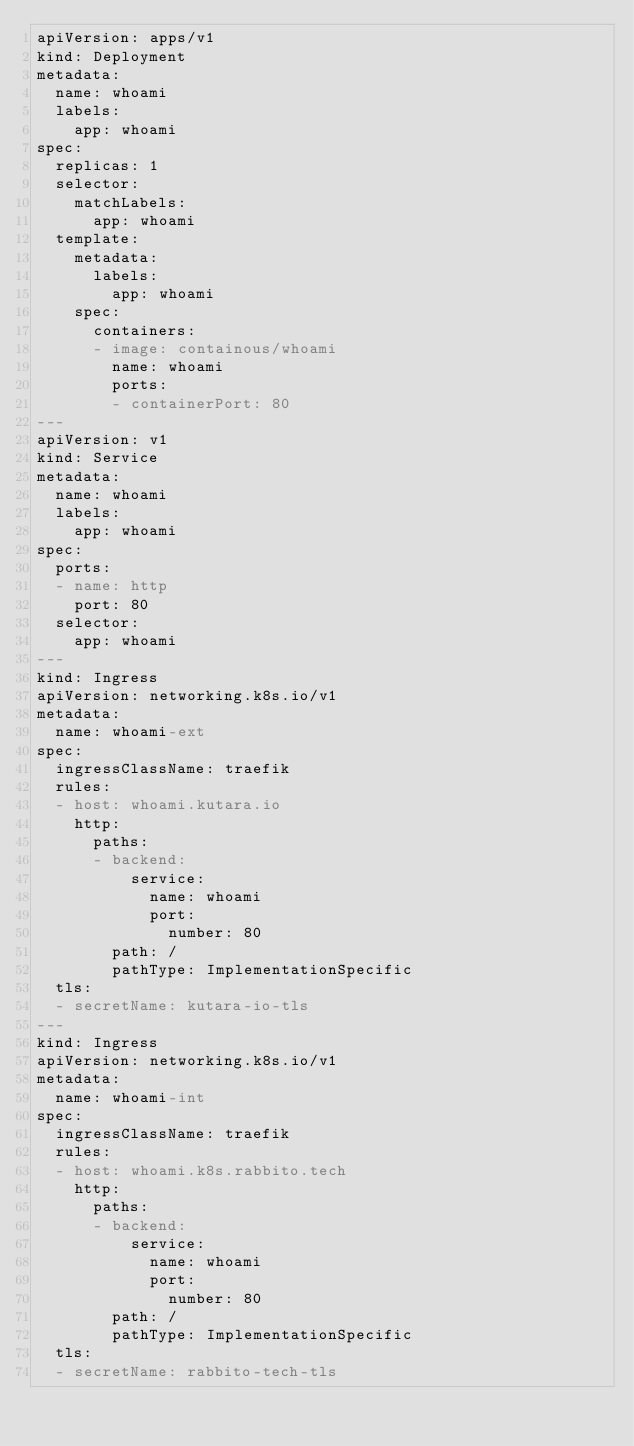Convert code to text. <code><loc_0><loc_0><loc_500><loc_500><_YAML_>apiVersion: apps/v1
kind: Deployment
metadata:
  name: whoami
  labels:
    app: whoami
spec:
  replicas: 1
  selector:
    matchLabels:
      app: whoami
  template:
    metadata:
      labels:
        app: whoami
    spec:
      containers:
      - image: containous/whoami
        name: whoami
        ports:
        - containerPort: 80
---
apiVersion: v1
kind: Service
metadata:
  name: whoami
  labels:
    app: whoami
spec:
  ports:
  - name: http
    port: 80
  selector:
    app: whoami
---
kind: Ingress
apiVersion: networking.k8s.io/v1
metadata:
  name: whoami-ext
spec:
  ingressClassName: traefik
  rules:
  - host: whoami.kutara.io
    http:
      paths:
      - backend:
          service:
            name: whoami
            port:
              number: 80
        path: /
        pathType: ImplementationSpecific
  tls:
  - secretName: kutara-io-tls
---
kind: Ingress
apiVersion: networking.k8s.io/v1
metadata:
  name: whoami-int
spec:
  ingressClassName: traefik
  rules:
  - host: whoami.k8s.rabbito.tech
    http:
      paths:
      - backend:
          service:
            name: whoami
            port:
              number: 80
        path: /
        pathType: ImplementationSpecific
  tls:
  - secretName: rabbito-tech-tls
</code> 